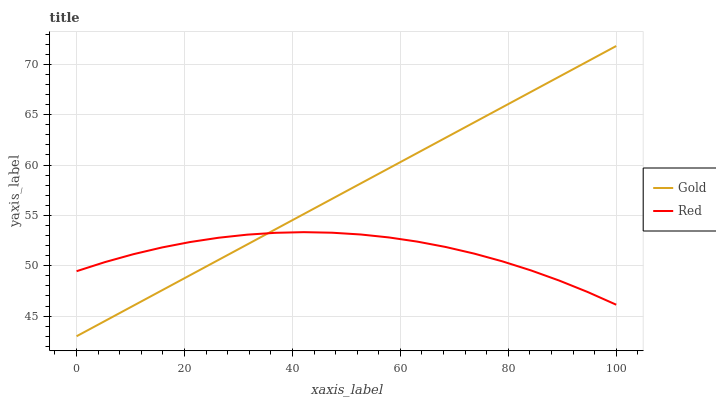Does Gold have the minimum area under the curve?
Answer yes or no. No. Is Gold the roughest?
Answer yes or no. No. 